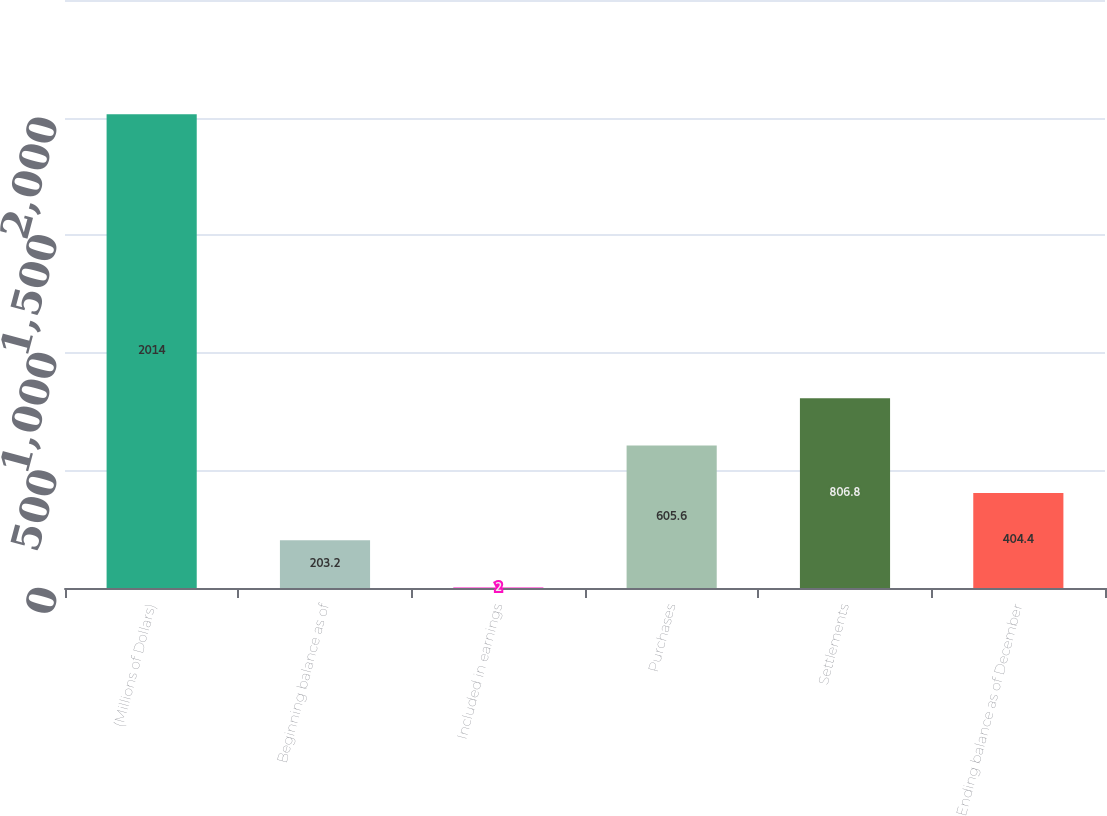<chart> <loc_0><loc_0><loc_500><loc_500><bar_chart><fcel>(Millions of Dollars)<fcel>Beginning balance as of<fcel>Included in earnings<fcel>Purchases<fcel>Settlements<fcel>Ending balance as of December<nl><fcel>2014<fcel>203.2<fcel>2<fcel>605.6<fcel>806.8<fcel>404.4<nl></chart> 